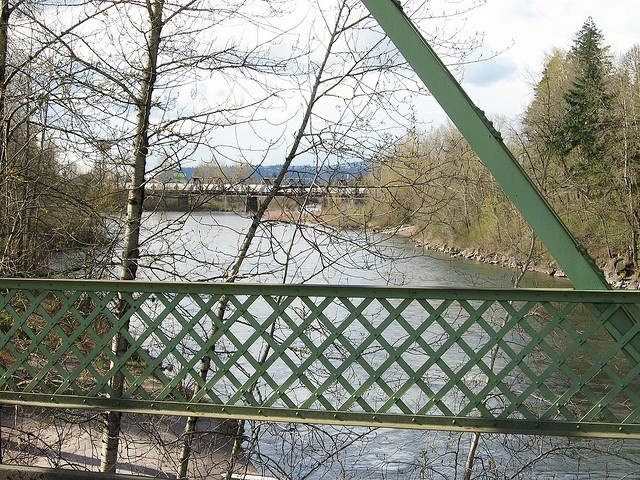Describe the objects in this image and their specific colors. I can see a train in lightgray, gray, darkgray, black, and ivory tones in this image. 